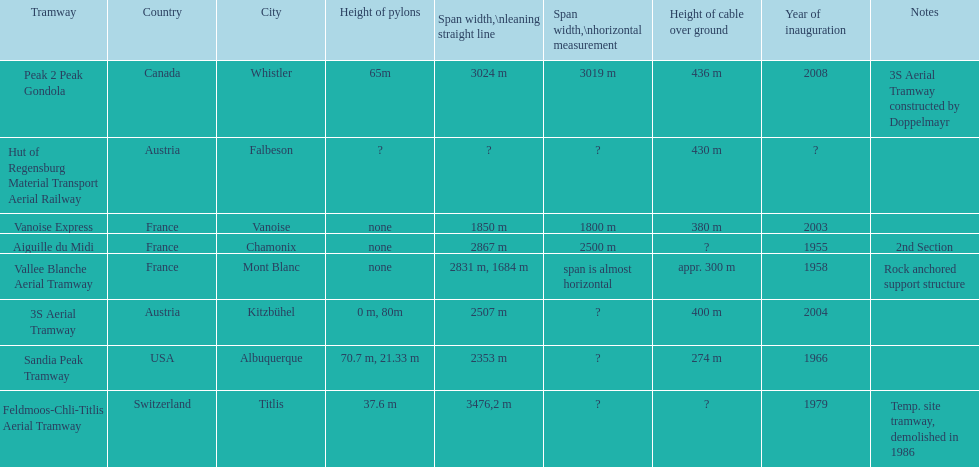Can you parse all the data within this table? {'header': ['Tramway', 'Country', 'City', 'Height of pylons', 'Span\xa0width,\\nleaning straight line', 'Span width,\\nhorizontal measurement', 'Height of cable over ground', 'Year of inauguration', 'Notes'], 'rows': [['Peak 2 Peak Gondola', 'Canada', 'Whistler', '65m', '3024 m', '3019 m', '436 m', '2008', '3S Aerial Tramway constructed by Doppelmayr'], ['Hut of Regensburg Material Transport Aerial Railway', 'Austria', 'Falbeson', '?', '?', '?', '430 m', '?', ''], ['Vanoise Express', 'France', 'Vanoise', 'none', '1850 m', '1800 m', '380 m', '2003', ''], ['Aiguille du Midi', 'France', 'Chamonix', 'none', '2867 m', '2500 m', '?', '1955', '2nd Section'], ['Vallee Blanche Aerial Tramway', 'France', 'Mont Blanc', 'none', '2831 m, 1684 m', 'span is almost horizontal', 'appr. 300 m', '1958', 'Rock anchored support structure'], ['3S Aerial Tramway', 'Austria', 'Kitzbühel', '0 m, 80m', '2507 m', '?', '400 m', '2004', ''], ['Sandia Peak Tramway', 'USA', 'Albuquerque', '70.7 m, 21.33 m', '2353 m', '?', '274 m', '1966', ''], ['Feldmoos-Chli-Titlis Aerial Tramway', 'Switzerland', 'Titlis', '37.6 m', '3476,2 m', '?', '?', '1979', 'Temp. site tramway, demolished in 1986']]} After 1970, how many aerial tramways were inaugurated at the very least? 4. 